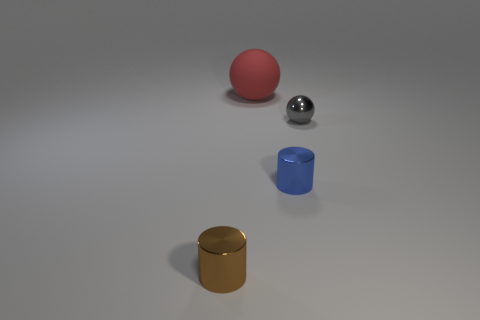What is the shape of the thing behind the sphere in front of the ball that is on the left side of the metallic sphere?
Give a very brief answer. Sphere. There is a metallic ball; is it the same size as the shiny cylinder that is on the right side of the red thing?
Your answer should be compact. Yes. What color is the thing that is to the left of the blue shiny cylinder and behind the brown shiny object?
Ensure brevity in your answer.  Red. What number of other things are the same shape as the blue shiny object?
Your answer should be compact. 1. There is a thing that is right of the blue metal cylinder; does it have the same size as the thing behind the shiny ball?
Your answer should be compact. No. Is there anything else that has the same material as the big thing?
Offer a terse response. No. What is the material of the tiny cylinder that is on the right side of the metal cylinder that is on the left side of the thing that is behind the gray shiny ball?
Your answer should be compact. Metal. Is the brown metal thing the same shape as the blue object?
Offer a very short reply. Yes. There is a tiny gray object that is the same shape as the big thing; what material is it?
Provide a short and direct response. Metal. How many yellow things are either tiny metal cylinders or rubber spheres?
Keep it short and to the point. 0. 